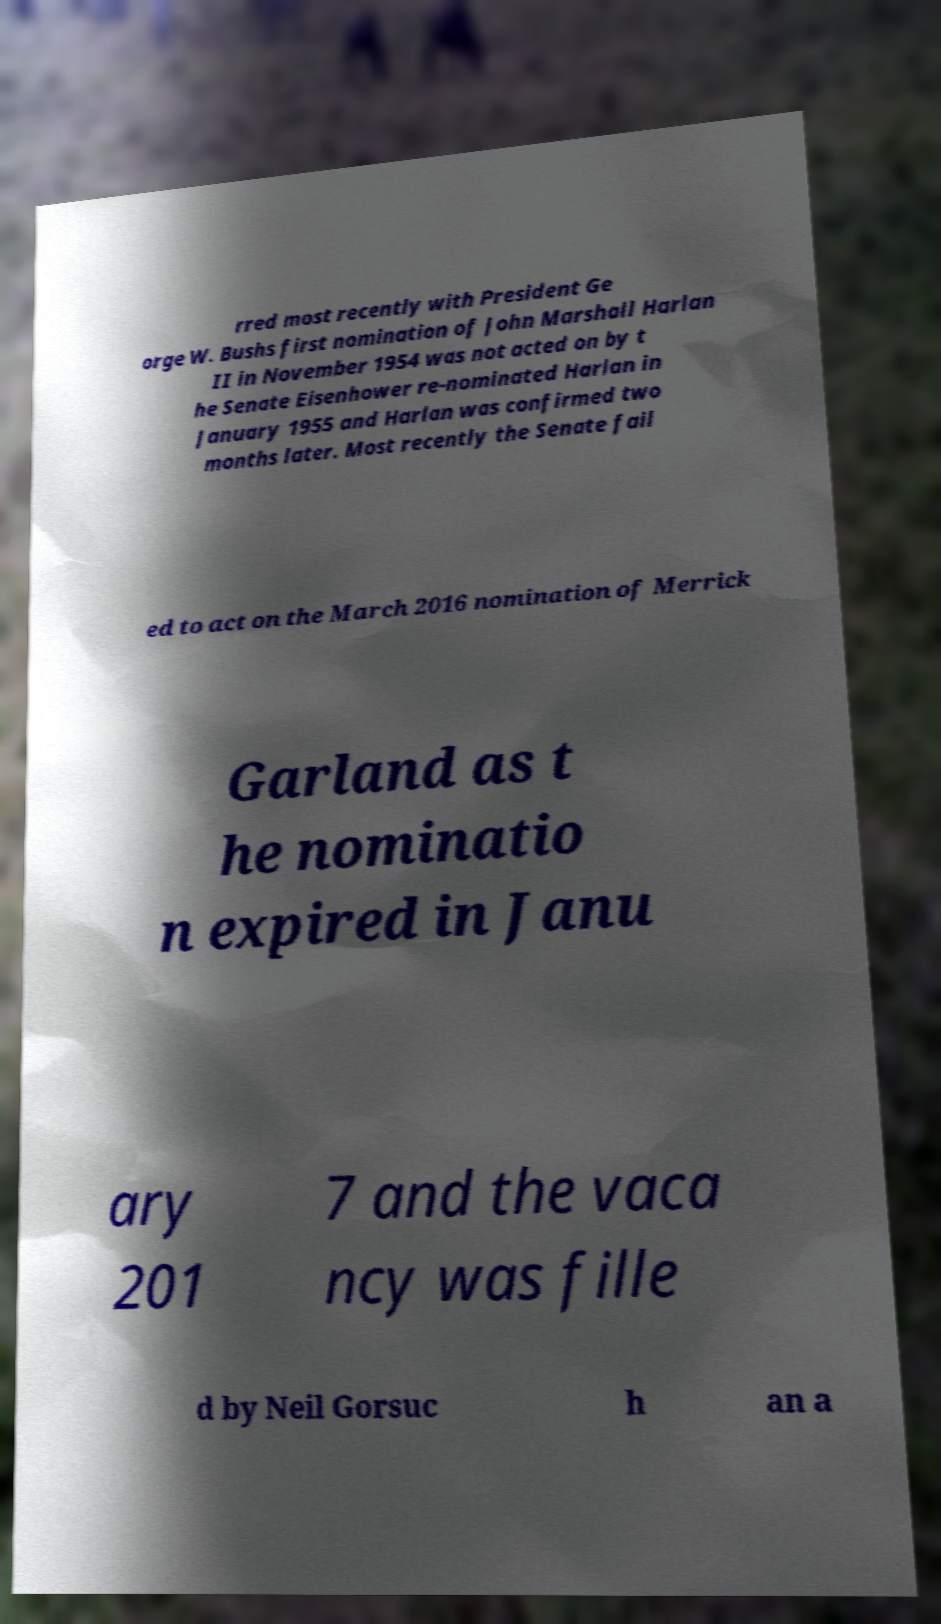There's text embedded in this image that I need extracted. Can you transcribe it verbatim? rred most recently with President Ge orge W. Bushs first nomination of John Marshall Harlan II in November 1954 was not acted on by t he Senate Eisenhower re-nominated Harlan in January 1955 and Harlan was confirmed two months later. Most recently the Senate fail ed to act on the March 2016 nomination of Merrick Garland as t he nominatio n expired in Janu ary 201 7 and the vaca ncy was fille d by Neil Gorsuc h an a 